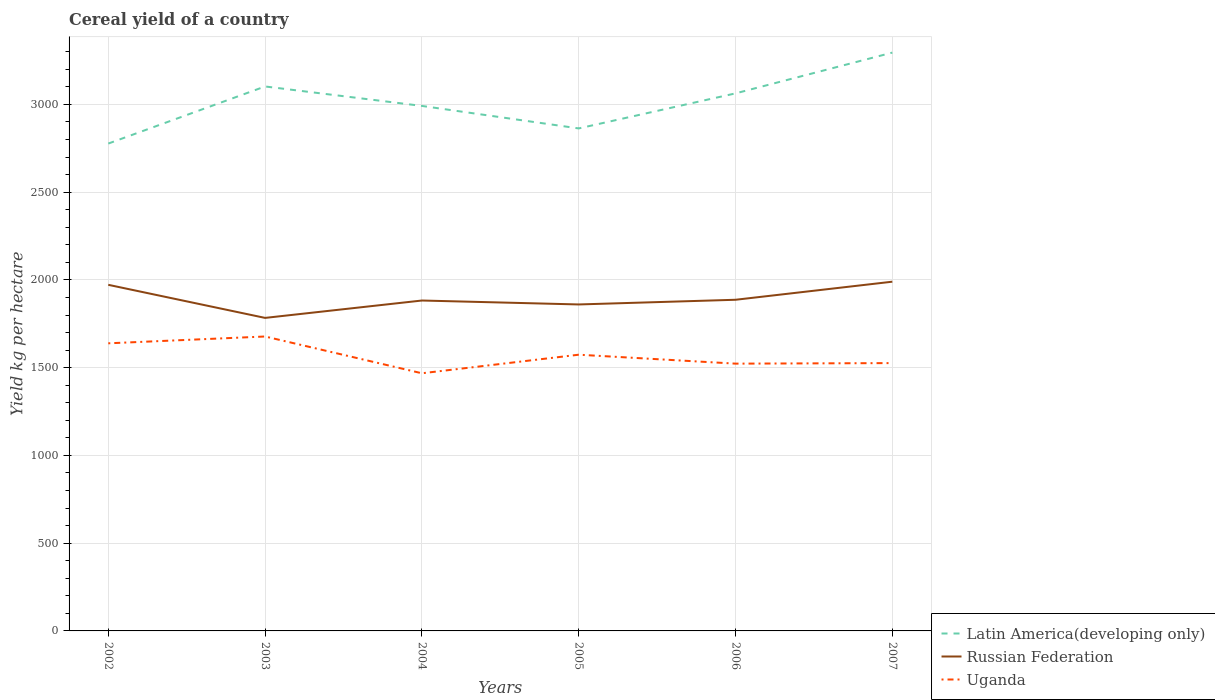How many different coloured lines are there?
Provide a short and direct response. 3. Across all years, what is the maximum total cereal yield in Russian Federation?
Provide a succinct answer. 1783.53. What is the total total cereal yield in Russian Federation in the graph?
Your response must be concise. -99.03. What is the difference between the highest and the second highest total cereal yield in Latin America(developing only)?
Provide a succinct answer. 518.27. What is the difference between the highest and the lowest total cereal yield in Uganda?
Offer a very short reply. 3. Is the total cereal yield in Latin America(developing only) strictly greater than the total cereal yield in Russian Federation over the years?
Your answer should be compact. No. How many lines are there?
Your answer should be compact. 3. How many years are there in the graph?
Offer a very short reply. 6. What is the difference between two consecutive major ticks on the Y-axis?
Give a very brief answer. 500. Does the graph contain any zero values?
Your response must be concise. No. Where does the legend appear in the graph?
Offer a terse response. Bottom right. How many legend labels are there?
Give a very brief answer. 3. What is the title of the graph?
Make the answer very short. Cereal yield of a country. What is the label or title of the X-axis?
Keep it short and to the point. Years. What is the label or title of the Y-axis?
Provide a succinct answer. Yield kg per hectare. What is the Yield kg per hectare in Latin America(developing only) in 2002?
Your answer should be very brief. 2776.87. What is the Yield kg per hectare of Russian Federation in 2002?
Your response must be concise. 1972.07. What is the Yield kg per hectare of Uganda in 2002?
Your answer should be compact. 1638.75. What is the Yield kg per hectare of Latin America(developing only) in 2003?
Give a very brief answer. 3102.27. What is the Yield kg per hectare in Russian Federation in 2003?
Provide a succinct answer. 1783.53. What is the Yield kg per hectare in Uganda in 2003?
Keep it short and to the point. 1677.59. What is the Yield kg per hectare of Latin America(developing only) in 2004?
Give a very brief answer. 2991.37. What is the Yield kg per hectare in Russian Federation in 2004?
Provide a short and direct response. 1882.56. What is the Yield kg per hectare in Uganda in 2004?
Keep it short and to the point. 1468.04. What is the Yield kg per hectare of Latin America(developing only) in 2005?
Offer a very short reply. 2863.19. What is the Yield kg per hectare of Russian Federation in 2005?
Give a very brief answer. 1860.17. What is the Yield kg per hectare of Uganda in 2005?
Ensure brevity in your answer.  1573.83. What is the Yield kg per hectare of Latin America(developing only) in 2006?
Provide a short and direct response. 3062.86. What is the Yield kg per hectare of Russian Federation in 2006?
Your answer should be very brief. 1886.86. What is the Yield kg per hectare of Uganda in 2006?
Provide a short and direct response. 1522.95. What is the Yield kg per hectare of Latin America(developing only) in 2007?
Your response must be concise. 3295.14. What is the Yield kg per hectare of Russian Federation in 2007?
Your answer should be compact. 1989.8. What is the Yield kg per hectare of Uganda in 2007?
Make the answer very short. 1526.02. Across all years, what is the maximum Yield kg per hectare in Latin America(developing only)?
Keep it short and to the point. 3295.14. Across all years, what is the maximum Yield kg per hectare of Russian Federation?
Offer a terse response. 1989.8. Across all years, what is the maximum Yield kg per hectare in Uganda?
Offer a very short reply. 1677.59. Across all years, what is the minimum Yield kg per hectare in Latin America(developing only)?
Your answer should be very brief. 2776.87. Across all years, what is the minimum Yield kg per hectare of Russian Federation?
Your response must be concise. 1783.53. Across all years, what is the minimum Yield kg per hectare in Uganda?
Offer a very short reply. 1468.04. What is the total Yield kg per hectare in Latin America(developing only) in the graph?
Make the answer very short. 1.81e+04. What is the total Yield kg per hectare in Russian Federation in the graph?
Provide a short and direct response. 1.14e+04. What is the total Yield kg per hectare of Uganda in the graph?
Your response must be concise. 9407.19. What is the difference between the Yield kg per hectare of Latin America(developing only) in 2002 and that in 2003?
Provide a succinct answer. -325.41. What is the difference between the Yield kg per hectare of Russian Federation in 2002 and that in 2003?
Provide a short and direct response. 188.53. What is the difference between the Yield kg per hectare in Uganda in 2002 and that in 2003?
Your answer should be very brief. -38.84. What is the difference between the Yield kg per hectare in Latin America(developing only) in 2002 and that in 2004?
Your response must be concise. -214.5. What is the difference between the Yield kg per hectare in Russian Federation in 2002 and that in 2004?
Ensure brevity in your answer.  89.51. What is the difference between the Yield kg per hectare of Uganda in 2002 and that in 2004?
Keep it short and to the point. 170.71. What is the difference between the Yield kg per hectare in Latin America(developing only) in 2002 and that in 2005?
Make the answer very short. -86.32. What is the difference between the Yield kg per hectare of Russian Federation in 2002 and that in 2005?
Provide a short and direct response. 111.9. What is the difference between the Yield kg per hectare in Uganda in 2002 and that in 2005?
Ensure brevity in your answer.  64.92. What is the difference between the Yield kg per hectare of Latin America(developing only) in 2002 and that in 2006?
Keep it short and to the point. -285.99. What is the difference between the Yield kg per hectare of Russian Federation in 2002 and that in 2006?
Make the answer very short. 85.21. What is the difference between the Yield kg per hectare in Uganda in 2002 and that in 2006?
Your response must be concise. 115.81. What is the difference between the Yield kg per hectare of Latin America(developing only) in 2002 and that in 2007?
Keep it short and to the point. -518.27. What is the difference between the Yield kg per hectare of Russian Federation in 2002 and that in 2007?
Give a very brief answer. -17.73. What is the difference between the Yield kg per hectare of Uganda in 2002 and that in 2007?
Your answer should be very brief. 112.74. What is the difference between the Yield kg per hectare of Latin America(developing only) in 2003 and that in 2004?
Offer a very short reply. 110.91. What is the difference between the Yield kg per hectare in Russian Federation in 2003 and that in 2004?
Provide a succinct answer. -99.03. What is the difference between the Yield kg per hectare of Uganda in 2003 and that in 2004?
Give a very brief answer. 209.55. What is the difference between the Yield kg per hectare of Latin America(developing only) in 2003 and that in 2005?
Keep it short and to the point. 239.08. What is the difference between the Yield kg per hectare of Russian Federation in 2003 and that in 2005?
Your answer should be compact. -76.63. What is the difference between the Yield kg per hectare of Uganda in 2003 and that in 2005?
Your answer should be very brief. 103.76. What is the difference between the Yield kg per hectare in Latin America(developing only) in 2003 and that in 2006?
Your response must be concise. 39.42. What is the difference between the Yield kg per hectare in Russian Federation in 2003 and that in 2006?
Provide a short and direct response. -103.32. What is the difference between the Yield kg per hectare of Uganda in 2003 and that in 2006?
Offer a terse response. 154.64. What is the difference between the Yield kg per hectare in Latin America(developing only) in 2003 and that in 2007?
Your answer should be compact. -192.86. What is the difference between the Yield kg per hectare of Russian Federation in 2003 and that in 2007?
Keep it short and to the point. -206.27. What is the difference between the Yield kg per hectare of Uganda in 2003 and that in 2007?
Provide a succinct answer. 151.57. What is the difference between the Yield kg per hectare in Latin America(developing only) in 2004 and that in 2005?
Your response must be concise. 128.18. What is the difference between the Yield kg per hectare in Russian Federation in 2004 and that in 2005?
Give a very brief answer. 22.4. What is the difference between the Yield kg per hectare in Uganda in 2004 and that in 2005?
Make the answer very short. -105.79. What is the difference between the Yield kg per hectare of Latin America(developing only) in 2004 and that in 2006?
Your response must be concise. -71.49. What is the difference between the Yield kg per hectare of Russian Federation in 2004 and that in 2006?
Provide a short and direct response. -4.29. What is the difference between the Yield kg per hectare of Uganda in 2004 and that in 2006?
Keep it short and to the point. -54.9. What is the difference between the Yield kg per hectare of Latin America(developing only) in 2004 and that in 2007?
Ensure brevity in your answer.  -303.77. What is the difference between the Yield kg per hectare in Russian Federation in 2004 and that in 2007?
Make the answer very short. -107.24. What is the difference between the Yield kg per hectare in Uganda in 2004 and that in 2007?
Offer a very short reply. -57.97. What is the difference between the Yield kg per hectare in Latin America(developing only) in 2005 and that in 2006?
Provide a short and direct response. -199.67. What is the difference between the Yield kg per hectare of Russian Federation in 2005 and that in 2006?
Keep it short and to the point. -26.69. What is the difference between the Yield kg per hectare in Uganda in 2005 and that in 2006?
Your answer should be compact. 50.88. What is the difference between the Yield kg per hectare in Latin America(developing only) in 2005 and that in 2007?
Your answer should be very brief. -431.95. What is the difference between the Yield kg per hectare in Russian Federation in 2005 and that in 2007?
Offer a terse response. -129.64. What is the difference between the Yield kg per hectare of Uganda in 2005 and that in 2007?
Your response must be concise. 47.81. What is the difference between the Yield kg per hectare of Latin America(developing only) in 2006 and that in 2007?
Your response must be concise. -232.28. What is the difference between the Yield kg per hectare in Russian Federation in 2006 and that in 2007?
Provide a short and direct response. -102.95. What is the difference between the Yield kg per hectare in Uganda in 2006 and that in 2007?
Ensure brevity in your answer.  -3.07. What is the difference between the Yield kg per hectare of Latin America(developing only) in 2002 and the Yield kg per hectare of Russian Federation in 2003?
Provide a short and direct response. 993.34. What is the difference between the Yield kg per hectare in Latin America(developing only) in 2002 and the Yield kg per hectare in Uganda in 2003?
Provide a short and direct response. 1099.28. What is the difference between the Yield kg per hectare in Russian Federation in 2002 and the Yield kg per hectare in Uganda in 2003?
Offer a terse response. 294.48. What is the difference between the Yield kg per hectare in Latin America(developing only) in 2002 and the Yield kg per hectare in Russian Federation in 2004?
Keep it short and to the point. 894.31. What is the difference between the Yield kg per hectare of Latin America(developing only) in 2002 and the Yield kg per hectare of Uganda in 2004?
Make the answer very short. 1308.83. What is the difference between the Yield kg per hectare in Russian Federation in 2002 and the Yield kg per hectare in Uganda in 2004?
Your answer should be very brief. 504.02. What is the difference between the Yield kg per hectare of Latin America(developing only) in 2002 and the Yield kg per hectare of Russian Federation in 2005?
Your answer should be compact. 916.7. What is the difference between the Yield kg per hectare in Latin America(developing only) in 2002 and the Yield kg per hectare in Uganda in 2005?
Your answer should be compact. 1203.04. What is the difference between the Yield kg per hectare in Russian Federation in 2002 and the Yield kg per hectare in Uganda in 2005?
Your response must be concise. 398.24. What is the difference between the Yield kg per hectare of Latin America(developing only) in 2002 and the Yield kg per hectare of Russian Federation in 2006?
Your answer should be compact. 890.01. What is the difference between the Yield kg per hectare of Latin America(developing only) in 2002 and the Yield kg per hectare of Uganda in 2006?
Ensure brevity in your answer.  1253.92. What is the difference between the Yield kg per hectare in Russian Federation in 2002 and the Yield kg per hectare in Uganda in 2006?
Your response must be concise. 449.12. What is the difference between the Yield kg per hectare of Latin America(developing only) in 2002 and the Yield kg per hectare of Russian Federation in 2007?
Make the answer very short. 787.07. What is the difference between the Yield kg per hectare of Latin America(developing only) in 2002 and the Yield kg per hectare of Uganda in 2007?
Provide a succinct answer. 1250.85. What is the difference between the Yield kg per hectare in Russian Federation in 2002 and the Yield kg per hectare in Uganda in 2007?
Keep it short and to the point. 446.05. What is the difference between the Yield kg per hectare in Latin America(developing only) in 2003 and the Yield kg per hectare in Russian Federation in 2004?
Ensure brevity in your answer.  1219.71. What is the difference between the Yield kg per hectare of Latin America(developing only) in 2003 and the Yield kg per hectare of Uganda in 2004?
Give a very brief answer. 1634.23. What is the difference between the Yield kg per hectare of Russian Federation in 2003 and the Yield kg per hectare of Uganda in 2004?
Make the answer very short. 315.49. What is the difference between the Yield kg per hectare of Latin America(developing only) in 2003 and the Yield kg per hectare of Russian Federation in 2005?
Give a very brief answer. 1242.11. What is the difference between the Yield kg per hectare of Latin America(developing only) in 2003 and the Yield kg per hectare of Uganda in 2005?
Make the answer very short. 1528.44. What is the difference between the Yield kg per hectare in Russian Federation in 2003 and the Yield kg per hectare in Uganda in 2005?
Ensure brevity in your answer.  209.7. What is the difference between the Yield kg per hectare of Latin America(developing only) in 2003 and the Yield kg per hectare of Russian Federation in 2006?
Make the answer very short. 1215.42. What is the difference between the Yield kg per hectare in Latin America(developing only) in 2003 and the Yield kg per hectare in Uganda in 2006?
Make the answer very short. 1579.33. What is the difference between the Yield kg per hectare of Russian Federation in 2003 and the Yield kg per hectare of Uganda in 2006?
Make the answer very short. 260.59. What is the difference between the Yield kg per hectare of Latin America(developing only) in 2003 and the Yield kg per hectare of Russian Federation in 2007?
Give a very brief answer. 1112.47. What is the difference between the Yield kg per hectare of Latin America(developing only) in 2003 and the Yield kg per hectare of Uganda in 2007?
Provide a succinct answer. 1576.26. What is the difference between the Yield kg per hectare of Russian Federation in 2003 and the Yield kg per hectare of Uganda in 2007?
Offer a very short reply. 257.52. What is the difference between the Yield kg per hectare of Latin America(developing only) in 2004 and the Yield kg per hectare of Russian Federation in 2005?
Provide a short and direct response. 1131.2. What is the difference between the Yield kg per hectare in Latin America(developing only) in 2004 and the Yield kg per hectare in Uganda in 2005?
Give a very brief answer. 1417.54. What is the difference between the Yield kg per hectare in Russian Federation in 2004 and the Yield kg per hectare in Uganda in 2005?
Your answer should be compact. 308.73. What is the difference between the Yield kg per hectare of Latin America(developing only) in 2004 and the Yield kg per hectare of Russian Federation in 2006?
Offer a terse response. 1104.51. What is the difference between the Yield kg per hectare of Latin America(developing only) in 2004 and the Yield kg per hectare of Uganda in 2006?
Ensure brevity in your answer.  1468.42. What is the difference between the Yield kg per hectare of Russian Federation in 2004 and the Yield kg per hectare of Uganda in 2006?
Keep it short and to the point. 359.62. What is the difference between the Yield kg per hectare of Latin America(developing only) in 2004 and the Yield kg per hectare of Russian Federation in 2007?
Your response must be concise. 1001.56. What is the difference between the Yield kg per hectare in Latin America(developing only) in 2004 and the Yield kg per hectare in Uganda in 2007?
Offer a very short reply. 1465.35. What is the difference between the Yield kg per hectare of Russian Federation in 2004 and the Yield kg per hectare of Uganda in 2007?
Make the answer very short. 356.55. What is the difference between the Yield kg per hectare of Latin America(developing only) in 2005 and the Yield kg per hectare of Russian Federation in 2006?
Make the answer very short. 976.33. What is the difference between the Yield kg per hectare of Latin America(developing only) in 2005 and the Yield kg per hectare of Uganda in 2006?
Give a very brief answer. 1340.24. What is the difference between the Yield kg per hectare in Russian Federation in 2005 and the Yield kg per hectare in Uganda in 2006?
Your response must be concise. 337.22. What is the difference between the Yield kg per hectare in Latin America(developing only) in 2005 and the Yield kg per hectare in Russian Federation in 2007?
Your answer should be compact. 873.39. What is the difference between the Yield kg per hectare in Latin America(developing only) in 2005 and the Yield kg per hectare in Uganda in 2007?
Your answer should be very brief. 1337.17. What is the difference between the Yield kg per hectare in Russian Federation in 2005 and the Yield kg per hectare in Uganda in 2007?
Offer a terse response. 334.15. What is the difference between the Yield kg per hectare of Latin America(developing only) in 2006 and the Yield kg per hectare of Russian Federation in 2007?
Your answer should be compact. 1073.05. What is the difference between the Yield kg per hectare of Latin America(developing only) in 2006 and the Yield kg per hectare of Uganda in 2007?
Your answer should be compact. 1536.84. What is the difference between the Yield kg per hectare of Russian Federation in 2006 and the Yield kg per hectare of Uganda in 2007?
Offer a very short reply. 360.84. What is the average Yield kg per hectare in Latin America(developing only) per year?
Offer a terse response. 3015.28. What is the average Yield kg per hectare of Russian Federation per year?
Ensure brevity in your answer.  1895.83. What is the average Yield kg per hectare of Uganda per year?
Offer a terse response. 1567.86. In the year 2002, what is the difference between the Yield kg per hectare in Latin America(developing only) and Yield kg per hectare in Russian Federation?
Provide a succinct answer. 804.8. In the year 2002, what is the difference between the Yield kg per hectare of Latin America(developing only) and Yield kg per hectare of Uganda?
Provide a short and direct response. 1138.12. In the year 2002, what is the difference between the Yield kg per hectare in Russian Federation and Yield kg per hectare in Uganda?
Provide a short and direct response. 333.31. In the year 2003, what is the difference between the Yield kg per hectare in Latin America(developing only) and Yield kg per hectare in Russian Federation?
Offer a terse response. 1318.74. In the year 2003, what is the difference between the Yield kg per hectare of Latin America(developing only) and Yield kg per hectare of Uganda?
Provide a short and direct response. 1424.68. In the year 2003, what is the difference between the Yield kg per hectare in Russian Federation and Yield kg per hectare in Uganda?
Give a very brief answer. 105.94. In the year 2004, what is the difference between the Yield kg per hectare of Latin America(developing only) and Yield kg per hectare of Russian Federation?
Your answer should be compact. 1108.81. In the year 2004, what is the difference between the Yield kg per hectare in Latin America(developing only) and Yield kg per hectare in Uganda?
Provide a short and direct response. 1523.32. In the year 2004, what is the difference between the Yield kg per hectare in Russian Federation and Yield kg per hectare in Uganda?
Give a very brief answer. 414.52. In the year 2005, what is the difference between the Yield kg per hectare of Latin America(developing only) and Yield kg per hectare of Russian Federation?
Offer a very short reply. 1003.02. In the year 2005, what is the difference between the Yield kg per hectare of Latin America(developing only) and Yield kg per hectare of Uganda?
Provide a succinct answer. 1289.36. In the year 2005, what is the difference between the Yield kg per hectare in Russian Federation and Yield kg per hectare in Uganda?
Offer a terse response. 286.33. In the year 2006, what is the difference between the Yield kg per hectare in Latin America(developing only) and Yield kg per hectare in Russian Federation?
Your answer should be very brief. 1176. In the year 2006, what is the difference between the Yield kg per hectare of Latin America(developing only) and Yield kg per hectare of Uganda?
Provide a short and direct response. 1539.91. In the year 2006, what is the difference between the Yield kg per hectare in Russian Federation and Yield kg per hectare in Uganda?
Make the answer very short. 363.91. In the year 2007, what is the difference between the Yield kg per hectare of Latin America(developing only) and Yield kg per hectare of Russian Federation?
Give a very brief answer. 1305.34. In the year 2007, what is the difference between the Yield kg per hectare of Latin America(developing only) and Yield kg per hectare of Uganda?
Ensure brevity in your answer.  1769.12. In the year 2007, what is the difference between the Yield kg per hectare in Russian Federation and Yield kg per hectare in Uganda?
Give a very brief answer. 463.79. What is the ratio of the Yield kg per hectare of Latin America(developing only) in 2002 to that in 2003?
Offer a very short reply. 0.9. What is the ratio of the Yield kg per hectare of Russian Federation in 2002 to that in 2003?
Your response must be concise. 1.11. What is the ratio of the Yield kg per hectare in Uganda in 2002 to that in 2003?
Ensure brevity in your answer.  0.98. What is the ratio of the Yield kg per hectare of Latin America(developing only) in 2002 to that in 2004?
Make the answer very short. 0.93. What is the ratio of the Yield kg per hectare of Russian Federation in 2002 to that in 2004?
Provide a short and direct response. 1.05. What is the ratio of the Yield kg per hectare of Uganda in 2002 to that in 2004?
Ensure brevity in your answer.  1.12. What is the ratio of the Yield kg per hectare of Latin America(developing only) in 2002 to that in 2005?
Make the answer very short. 0.97. What is the ratio of the Yield kg per hectare of Russian Federation in 2002 to that in 2005?
Keep it short and to the point. 1.06. What is the ratio of the Yield kg per hectare of Uganda in 2002 to that in 2005?
Your answer should be compact. 1.04. What is the ratio of the Yield kg per hectare of Latin America(developing only) in 2002 to that in 2006?
Your answer should be compact. 0.91. What is the ratio of the Yield kg per hectare of Russian Federation in 2002 to that in 2006?
Make the answer very short. 1.05. What is the ratio of the Yield kg per hectare of Uganda in 2002 to that in 2006?
Provide a short and direct response. 1.08. What is the ratio of the Yield kg per hectare in Latin America(developing only) in 2002 to that in 2007?
Offer a very short reply. 0.84. What is the ratio of the Yield kg per hectare in Uganda in 2002 to that in 2007?
Your response must be concise. 1.07. What is the ratio of the Yield kg per hectare in Latin America(developing only) in 2003 to that in 2004?
Ensure brevity in your answer.  1.04. What is the ratio of the Yield kg per hectare of Uganda in 2003 to that in 2004?
Your response must be concise. 1.14. What is the ratio of the Yield kg per hectare of Latin America(developing only) in 2003 to that in 2005?
Your response must be concise. 1.08. What is the ratio of the Yield kg per hectare of Russian Federation in 2003 to that in 2005?
Give a very brief answer. 0.96. What is the ratio of the Yield kg per hectare of Uganda in 2003 to that in 2005?
Make the answer very short. 1.07. What is the ratio of the Yield kg per hectare of Latin America(developing only) in 2003 to that in 2006?
Make the answer very short. 1.01. What is the ratio of the Yield kg per hectare in Russian Federation in 2003 to that in 2006?
Offer a very short reply. 0.95. What is the ratio of the Yield kg per hectare in Uganda in 2003 to that in 2006?
Provide a succinct answer. 1.1. What is the ratio of the Yield kg per hectare in Latin America(developing only) in 2003 to that in 2007?
Your response must be concise. 0.94. What is the ratio of the Yield kg per hectare in Russian Federation in 2003 to that in 2007?
Your answer should be very brief. 0.9. What is the ratio of the Yield kg per hectare of Uganda in 2003 to that in 2007?
Your response must be concise. 1.1. What is the ratio of the Yield kg per hectare in Latin America(developing only) in 2004 to that in 2005?
Provide a succinct answer. 1.04. What is the ratio of the Yield kg per hectare of Uganda in 2004 to that in 2005?
Make the answer very short. 0.93. What is the ratio of the Yield kg per hectare of Latin America(developing only) in 2004 to that in 2006?
Make the answer very short. 0.98. What is the ratio of the Yield kg per hectare of Uganda in 2004 to that in 2006?
Your answer should be very brief. 0.96. What is the ratio of the Yield kg per hectare of Latin America(developing only) in 2004 to that in 2007?
Provide a short and direct response. 0.91. What is the ratio of the Yield kg per hectare in Russian Federation in 2004 to that in 2007?
Make the answer very short. 0.95. What is the ratio of the Yield kg per hectare of Uganda in 2004 to that in 2007?
Provide a short and direct response. 0.96. What is the ratio of the Yield kg per hectare of Latin America(developing only) in 2005 to that in 2006?
Provide a succinct answer. 0.93. What is the ratio of the Yield kg per hectare of Russian Federation in 2005 to that in 2006?
Ensure brevity in your answer.  0.99. What is the ratio of the Yield kg per hectare of Uganda in 2005 to that in 2006?
Offer a very short reply. 1.03. What is the ratio of the Yield kg per hectare of Latin America(developing only) in 2005 to that in 2007?
Your answer should be very brief. 0.87. What is the ratio of the Yield kg per hectare of Russian Federation in 2005 to that in 2007?
Your answer should be compact. 0.93. What is the ratio of the Yield kg per hectare in Uganda in 2005 to that in 2007?
Give a very brief answer. 1.03. What is the ratio of the Yield kg per hectare of Latin America(developing only) in 2006 to that in 2007?
Offer a terse response. 0.93. What is the ratio of the Yield kg per hectare of Russian Federation in 2006 to that in 2007?
Give a very brief answer. 0.95. What is the ratio of the Yield kg per hectare of Uganda in 2006 to that in 2007?
Your response must be concise. 1. What is the difference between the highest and the second highest Yield kg per hectare of Latin America(developing only)?
Provide a short and direct response. 192.86. What is the difference between the highest and the second highest Yield kg per hectare in Russian Federation?
Ensure brevity in your answer.  17.73. What is the difference between the highest and the second highest Yield kg per hectare in Uganda?
Ensure brevity in your answer.  38.84. What is the difference between the highest and the lowest Yield kg per hectare of Latin America(developing only)?
Your answer should be very brief. 518.27. What is the difference between the highest and the lowest Yield kg per hectare in Russian Federation?
Ensure brevity in your answer.  206.27. What is the difference between the highest and the lowest Yield kg per hectare of Uganda?
Give a very brief answer. 209.55. 